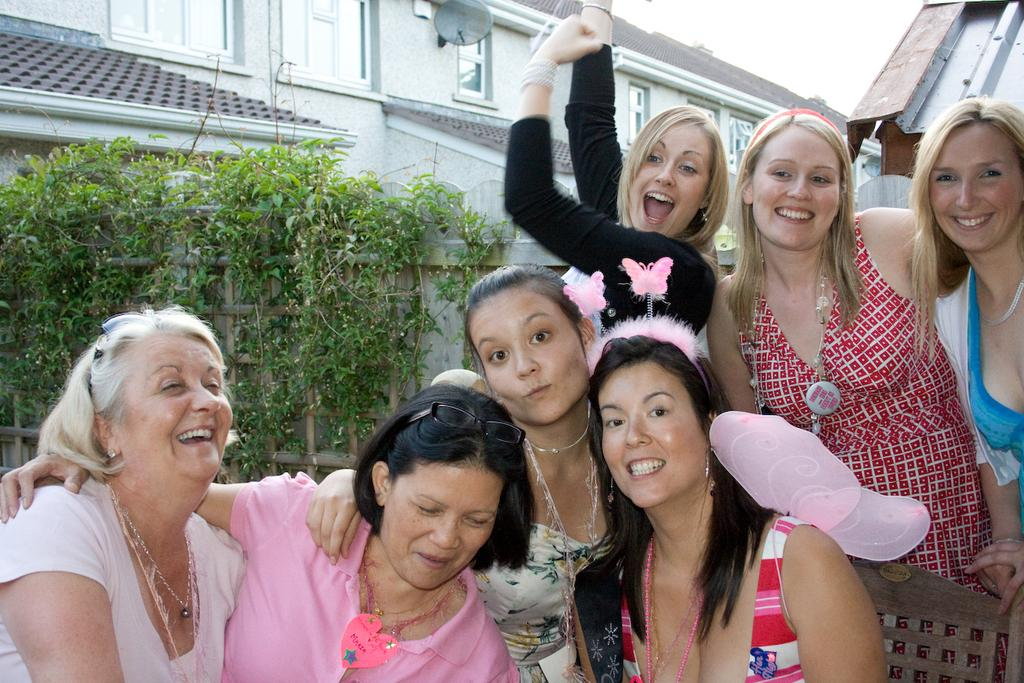What is the main subject in the center of the image? There is a group of women in the center of the image. What can be seen in the background of the image? There are plants, a wall, a building, a dish, and the sky visible in the background of the image. Where is the writer sitting in the image? There is no writer present in the image. What type of board is being used by the group of women in the image? There is no board visible in the image; the group of women is the main subject. 